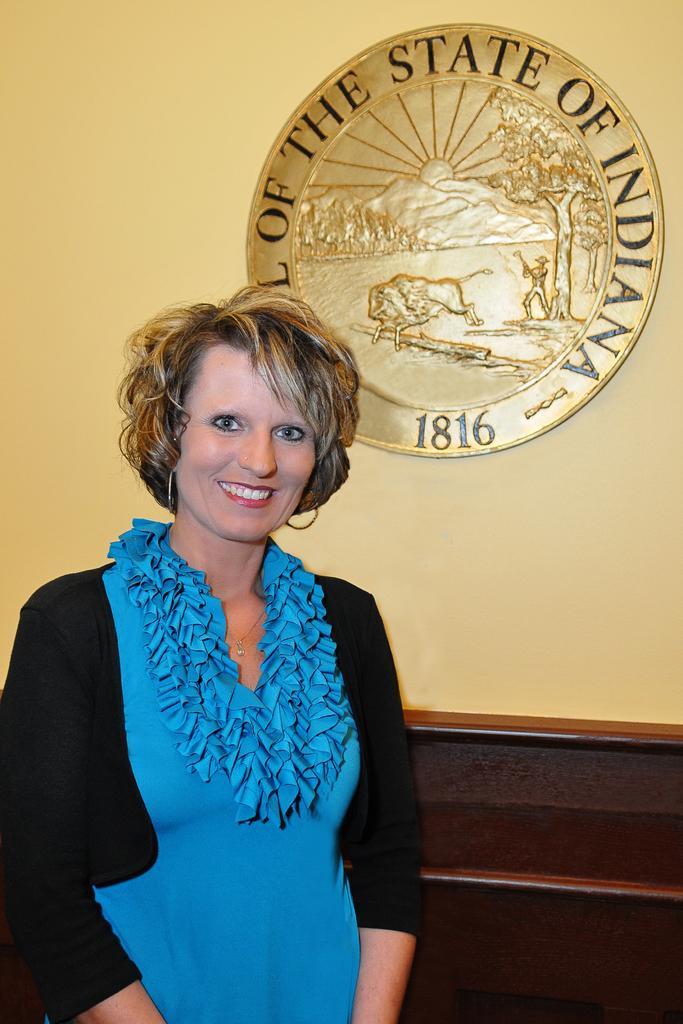How would you summarize this image in a sentence or two? Front this woman is standing and smiling. Shield is on the wall. Backside of this woman there is a table. 